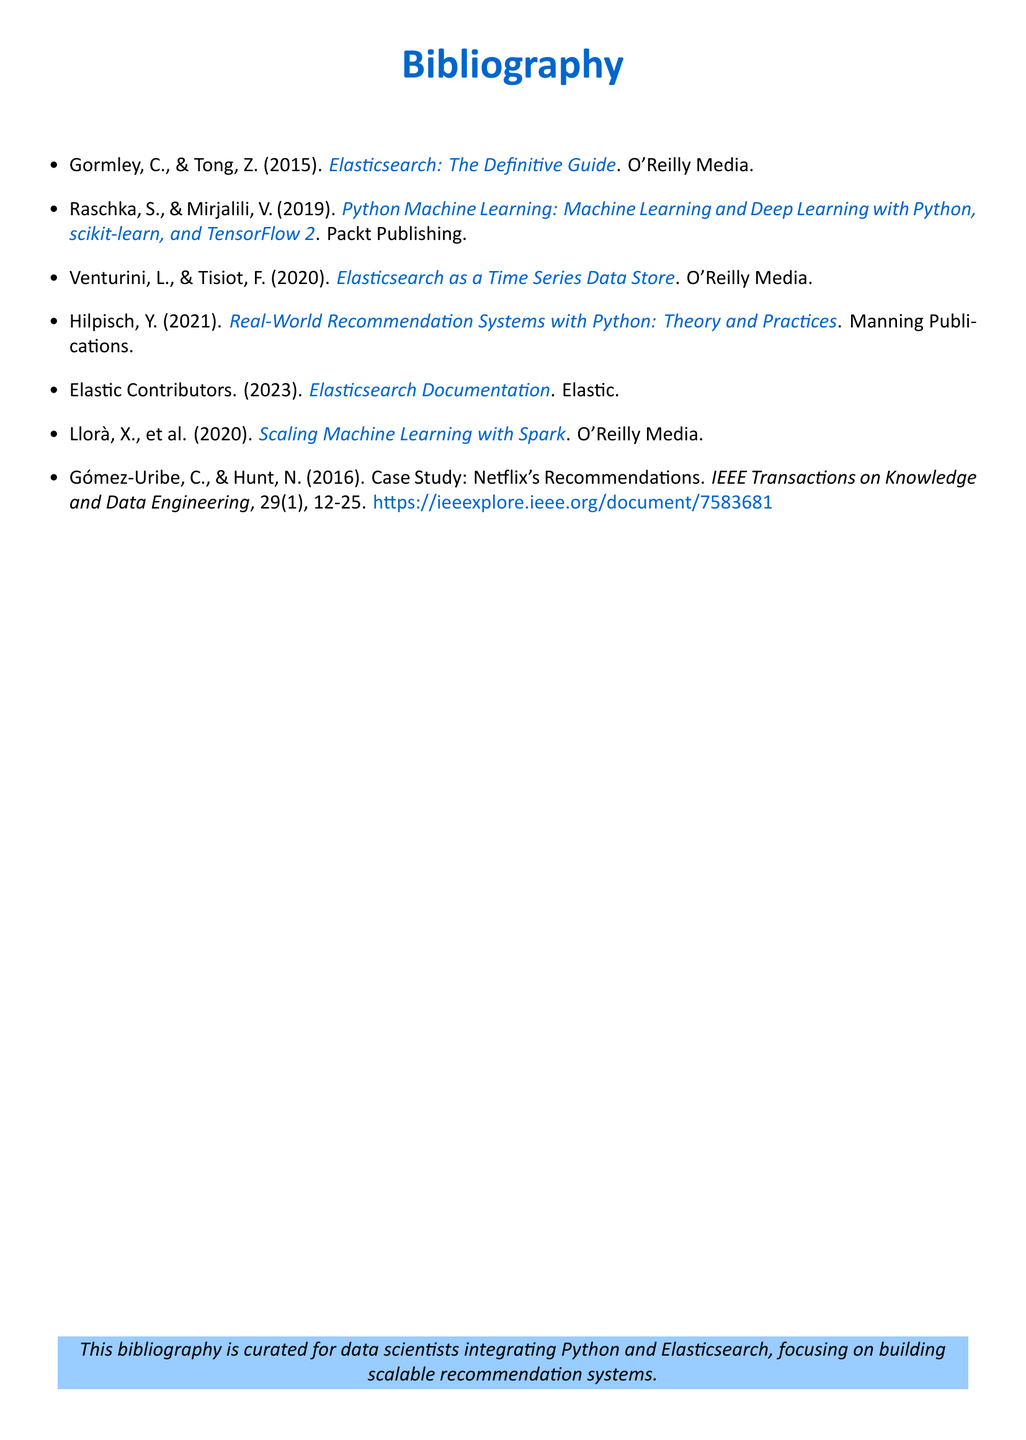What is the title of the first reference? The first reference listed is "Elasticsearch: The Definitive Guide."
Answer: Elasticsearch: The Definitive Guide Who are the authors of the book on machine learning? The authors of the book on machine learning are Sebastian Raschka and Vahid Mirjalili.
Answer: Sebastian Raschka, Vahid Mirjalili In what year was "Real-World Recommendation Systems with Python" published? The book "Real-World Recommendation Systems with Python" was published in 2021.
Answer: 2021 How many case studies are mentioned in the document? The document mentions one case study, specifically Netflix's recommendations.
Answer: One What is the publisher of the "Scaling Machine Learning with Spark"? The publisher of "Scaling Machine Learning with Spark" is O'Reilly Media.
Answer: O'Reilly Media Which authors collaborated on the case study about Netflix's recommendations? The authors of the case study about Netflix's recommendations are Gómez-Uribe and Hunt.
Answer: Gómez-Uribe, Hunt What type of resource is the "Elasticsearch Documentation"? The "Elasticsearch Documentation" is categorized as a technical reference resource.
Answer: Technical reference What is the main subject of the bibliography? The main subject of the bibliography is about integrating Python and Elasticsearch for recommendation systems.
Answer: Integrating Python and Elasticsearch for recommendation systems 